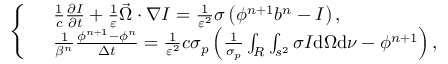Convert formula to latex. <formula><loc_0><loc_0><loc_500><loc_500>\left \{ \begin{array} { r l } & { \frac { 1 } { c } \frac { \partial I } { \partial t } + \frac { 1 } { \varepsilon } \vec { \Omega } \cdot \nabla I = \frac { 1 } { \varepsilon ^ { 2 } } \sigma \left ( \phi ^ { n + 1 } b ^ { n } - I \right ) , } \\ & { \frac { 1 } { \beta ^ { n } } \frac { \phi ^ { n + 1 } - \phi ^ { n } } { \Delta t } = \frac { 1 } { \varepsilon ^ { 2 } } c \sigma _ { p } \left ( \frac { 1 } { \sigma _ { p } } \int _ { R } \int _ { s ^ { 2 } } \sigma I d \Omega d \nu - \phi ^ { n + 1 } \right ) , } \end{array}</formula> 